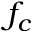<formula> <loc_0><loc_0><loc_500><loc_500>f _ { c }</formula> 